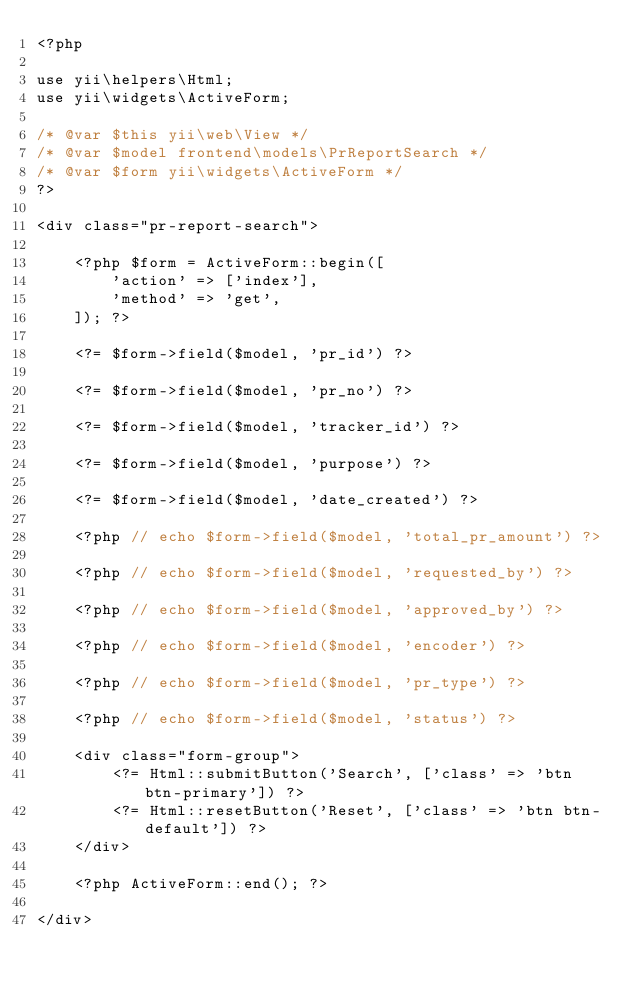<code> <loc_0><loc_0><loc_500><loc_500><_PHP_><?php

use yii\helpers\Html;
use yii\widgets\ActiveForm;

/* @var $this yii\web\View */
/* @var $model frontend\models\PrReportSearch */
/* @var $form yii\widgets\ActiveForm */
?>

<div class="pr-report-search">

    <?php $form = ActiveForm::begin([
        'action' => ['index'],
        'method' => 'get',
    ]); ?>

    <?= $form->field($model, 'pr_id') ?>

    <?= $form->field($model, 'pr_no') ?>

    <?= $form->field($model, 'tracker_id') ?>

    <?= $form->field($model, 'purpose') ?>

    <?= $form->field($model, 'date_created') ?>

    <?php // echo $form->field($model, 'total_pr_amount') ?>

    <?php // echo $form->field($model, 'requested_by') ?>

    <?php // echo $form->field($model, 'approved_by') ?>

    <?php // echo $form->field($model, 'encoder') ?>

    <?php // echo $form->field($model, 'pr_type') ?>

    <?php // echo $form->field($model, 'status') ?>

    <div class="form-group">
        <?= Html::submitButton('Search', ['class' => 'btn btn-primary']) ?>
        <?= Html::resetButton('Reset', ['class' => 'btn btn-default']) ?>
    </div>

    <?php ActiveForm::end(); ?>

</div>
</code> 